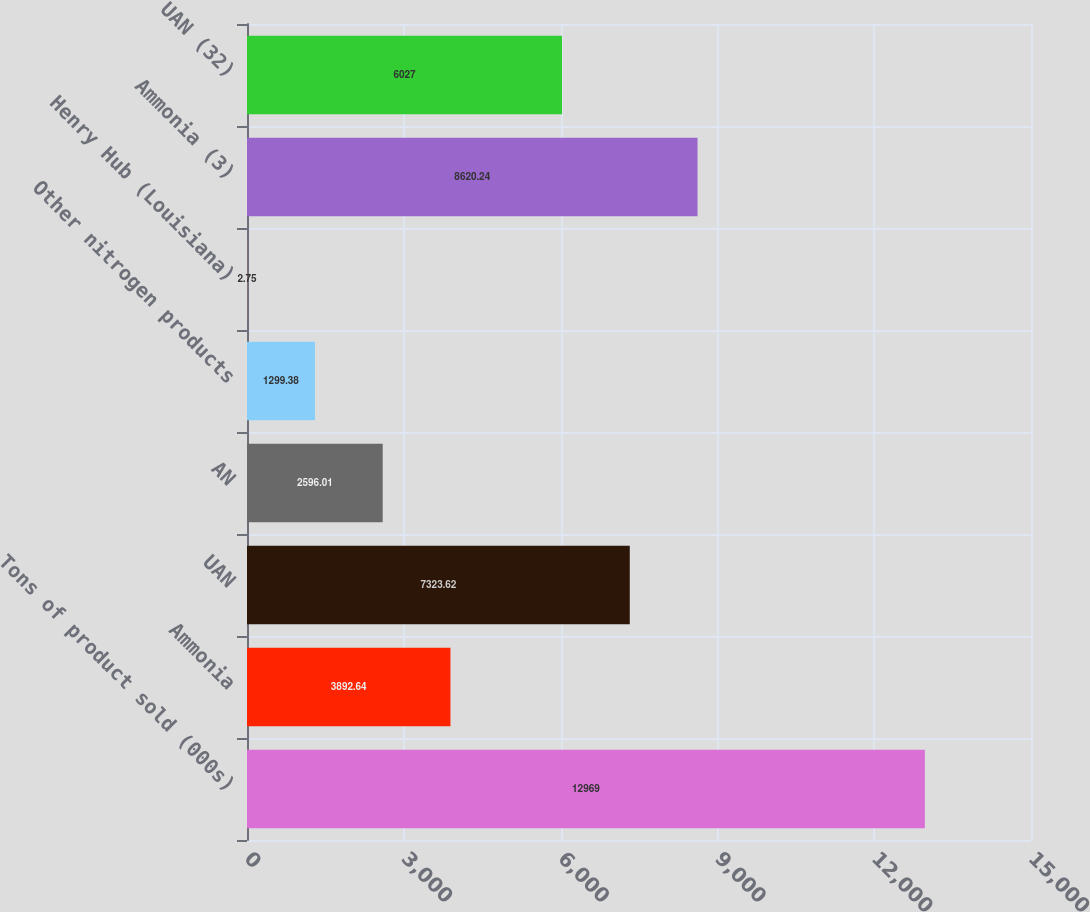Convert chart. <chart><loc_0><loc_0><loc_500><loc_500><bar_chart><fcel>Tons of product sold (000s)<fcel>Ammonia<fcel>UAN<fcel>AN<fcel>Other nitrogen products<fcel>Henry Hub (Louisiana)<fcel>Ammonia (3)<fcel>UAN (32)<nl><fcel>12969<fcel>3892.64<fcel>7323.62<fcel>2596.01<fcel>1299.38<fcel>2.75<fcel>8620.24<fcel>6027<nl></chart> 